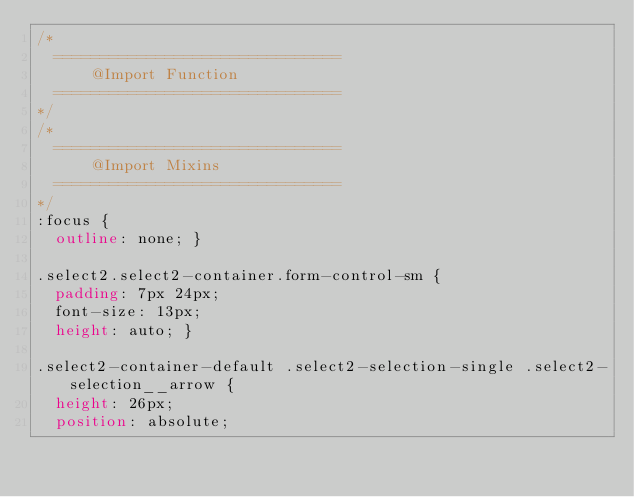<code> <loc_0><loc_0><loc_500><loc_500><_CSS_>/*
	===============================
			@Import	Function
	===============================
*/
/*
	===============================
			@Import	Mixins
	===============================
*/
:focus {
  outline: none; }

.select2.select2-container.form-control-sm {
  padding: 7px 24px;
  font-size: 13px;
  height: auto; }

.select2-container-default .select2-selection-single .select2-selection__arrow {
  height: 26px;
  position: absolute;</code> 